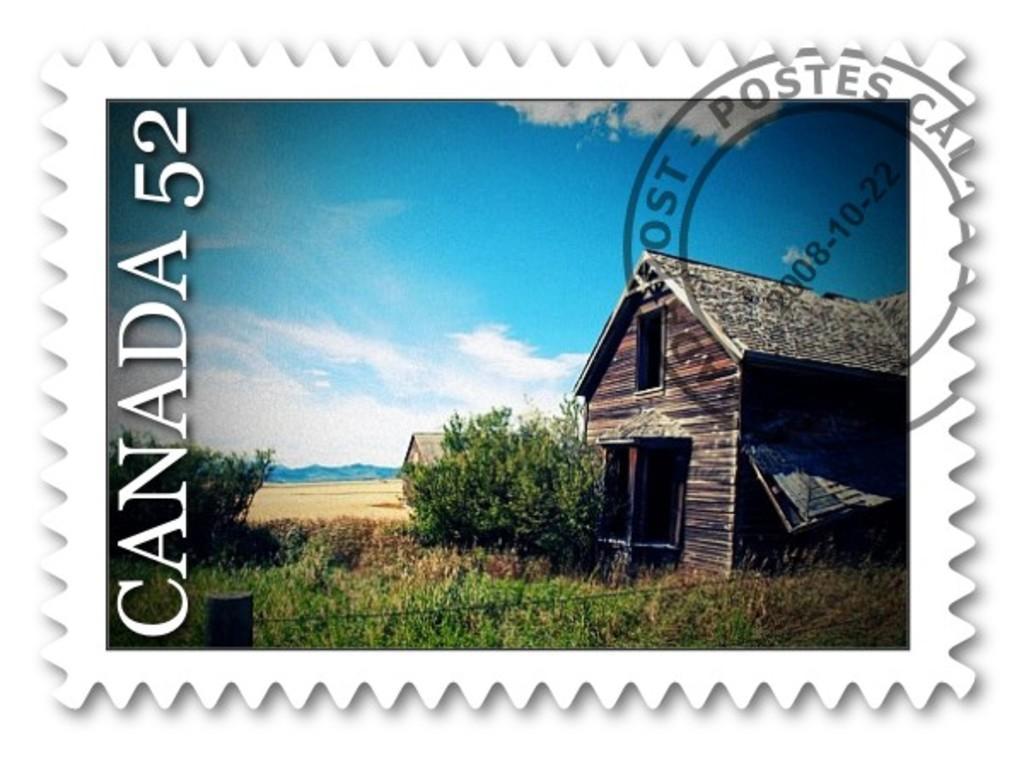Could you give a brief overview of what you see in this image? In this image there is a postage stamp. 